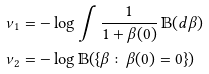Convert formula to latex. <formula><loc_0><loc_0><loc_500><loc_500>\nu _ { 1 } & = - \log \int \frac { 1 } { 1 + \beta ( 0 ) } \, \mathbb { B } ( d \beta ) \\ \nu _ { 2 } & = - \log \mathbb { B } ( \{ \beta \colon \beta ( 0 ) = 0 \} )</formula> 